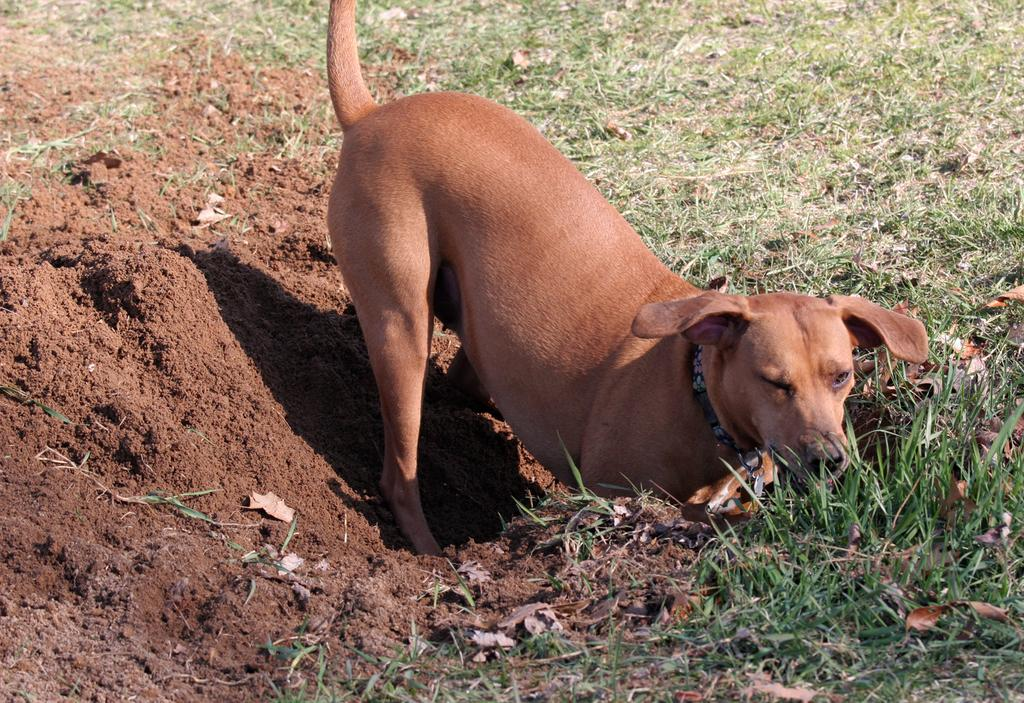What type of animal is in the image? There is a dog in the image. What color is the dog? The dog is brown in color. What type of terrain is visible in the image? There is mud and grass visible in the image. What flavor of gun can be seen in the image? There is no gun present in the image, so it is not possible to determine its flavor. 